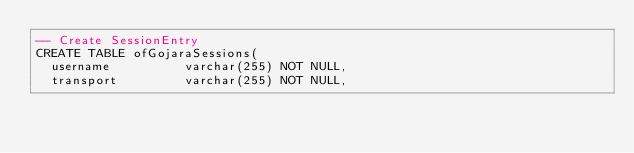<code> <loc_0><loc_0><loc_500><loc_500><_SQL_>-- Create SessionEntry 
CREATE TABLE ofGojaraSessions(
  username 			varchar(255) NOT NULL,
  transport 		varchar(255) NOT NULL,</code> 